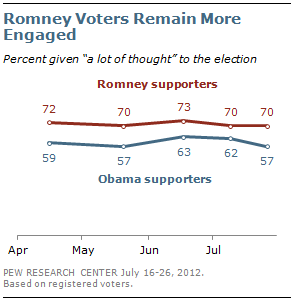Identify some key points in this picture. The blue line represents the support of Obama supporters. The minimum value of the line on top is 70. 